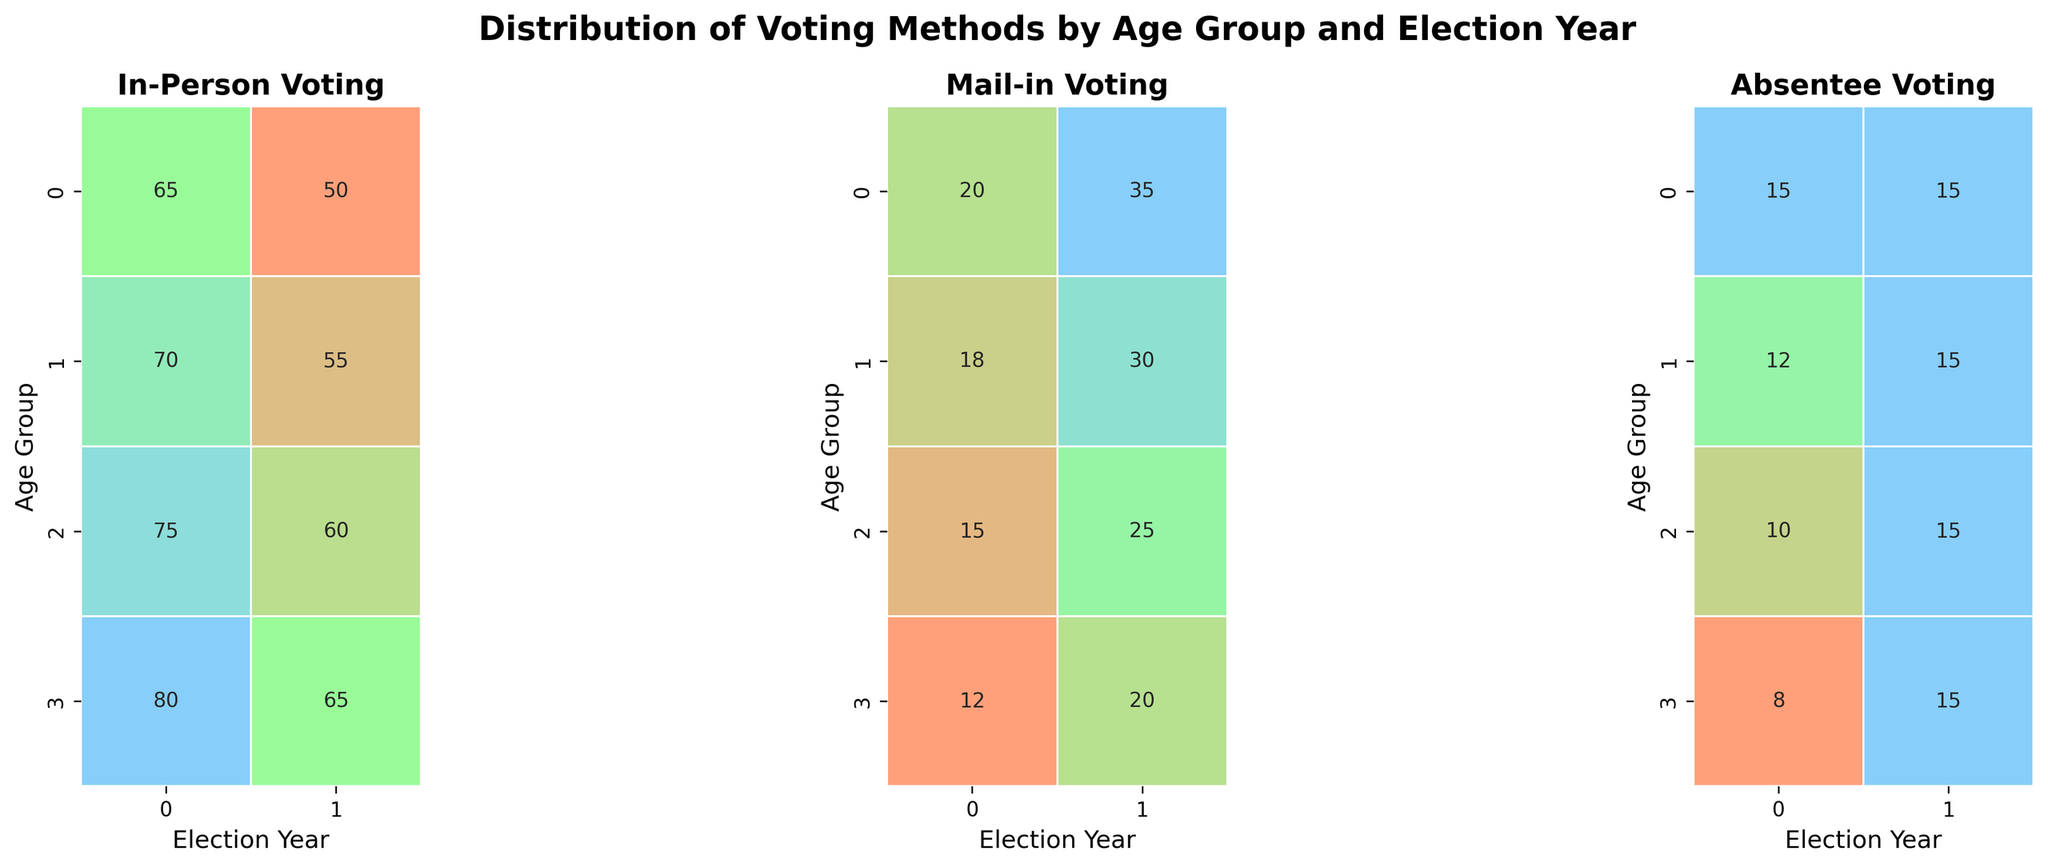What are the three different voting methods depicted in the heatmaps? The three different voting methods are the titles of the individual heatmaps. They are "In-Person Voting," "Mail-in Voting," and "Absentee Voting."
Answer: In-Person Voting, Mail-in Voting, Absentee Voting What is the highest percentage of in-person voting for the 18-29 age group, and in which year did it occur? Look at the heatmap for "In-Person Voting" and find the cell corresponding to the 18-29 age group. The highest percentage is 65%, which occurred in the year 2016.
Answer: 65%, 2016 How did mail-in voting change for the 45-59 age group between 2016 and 2020? Check the "Mail-in Voting" heatmap for the 45-59 age group. In 2016, it was 15%, and in 2020, it increased to 25%. Therefore, it increased by 10 percentage points.
Answer: Increased by 10 percentage points Which age group had the biggest difference in absentee voting between 2016 and 2020? Look at the "Absentee Voting" heatmap. Calculate the differences between 2016 and 2020 for each age group: 0 for 18-29, 3 for 30-44, 5 for 45-59, and 7 for 60+. The 60+ age group had the biggest difference of 7 percentage points.
Answer: 60+ How does the percentage of in-person voting for the 30-44 age group in 2020 compare to the 18-29 age group in the same year? In the "In-Person Voting" heatmap, check the values for 2020 for both age groups. The 30-44 age group has 55%, while the 18-29 age group has 50%. So, it is 5 percentage points higher for the 30-44 age group.
Answer: 5 percentage points higher What was the most common voting method for the 60+ age group in 2016? For the 60+ age group in 2016 across all three heatmaps, the percentages are: 80% In-Person Voting, 12% Mail-in Voting, and 8% Absentee Voting. The most common method was In-Person Voting at 80%.
Answer: In-Person Voting Compare the overall trend in absentee voting for all age groups between 2016 and 2020. What do you notice? In the "Absentee Voting" heatmap, each age group increased their absentee voting from 2016 to 2020. Values went from 15 to 15 for 18-29, 12 to 15 for 30-44, 10 to 15 for 45-59, and 8 to 15 for 60+. There was an upward trend in absentee voting across all age groups.
Answer: Upward trend across all age groups Which voting method experienced the largest increase for the 18-29 age group between 2016 and 2020? For the 18-29 age group across the heatmaps, observe the changes: In-Person Voting decreased from 65 to 50 (-15), Mail-in Voting increased from 20 to 35 (+15), Absentee Voting stayed the same at 15. Mail-in Voting experienced the largest increase of 15 percentage points.
Answer: Mail-in Voting What was the smallest percentage of mail-in voting observed in any age group for any election year? Check the "Mail-in Voting" heatmap for the smallest value across all cells. The smallest percentage is 12%, observed for the 60+ age group in 2016.
Answer: 12%, 60+, 2016 